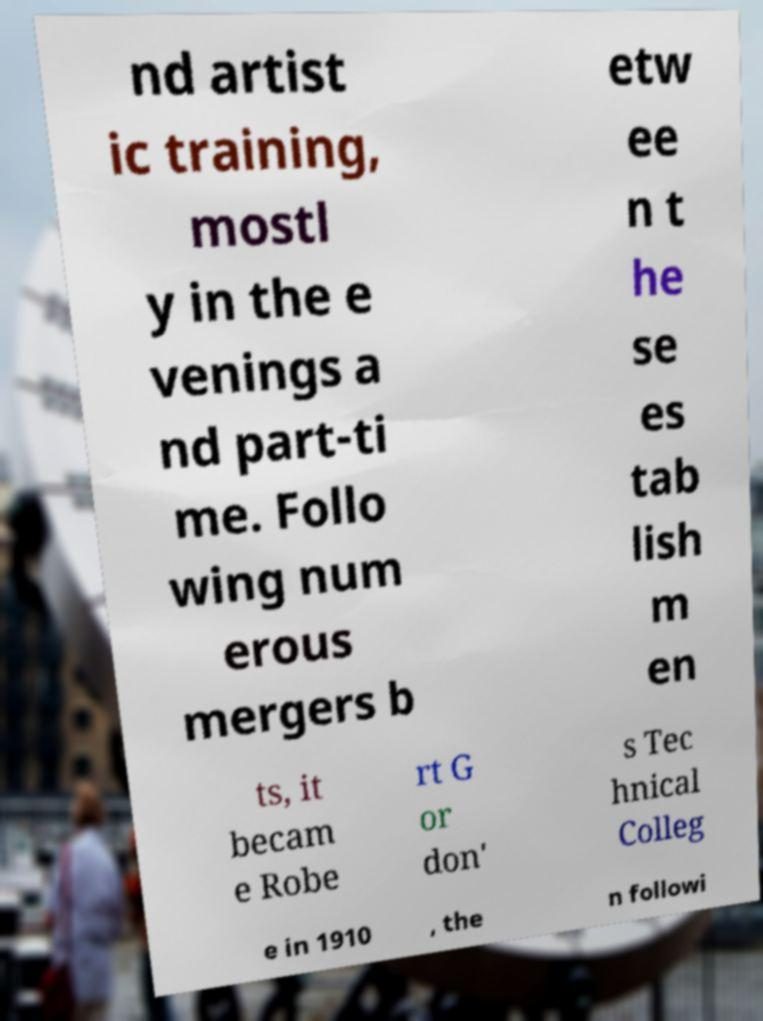There's text embedded in this image that I need extracted. Can you transcribe it verbatim? nd artist ic training, mostl y in the e venings a nd part-ti me. Follo wing num erous mergers b etw ee n t he se es tab lish m en ts, it becam e Robe rt G or don' s Tec hnical Colleg e in 1910 , the n followi 